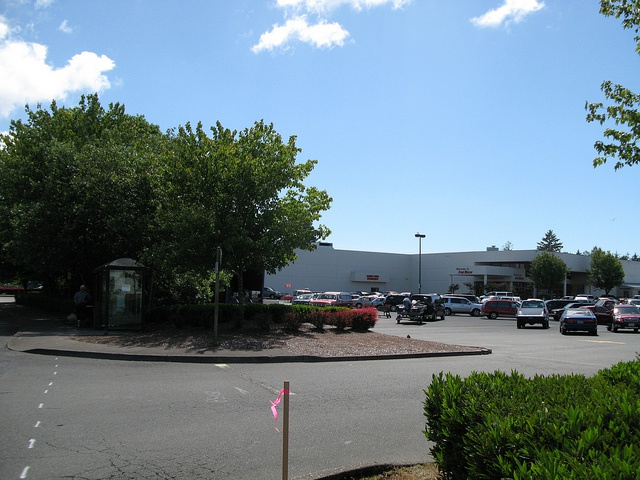Describe the objects in this image and their specific colors. I can see truck in lightblue, black, gray, and darkgray tones, car in lightblue, black, darkgray, and gray tones, car in lightblue, black, gray, blue, and darkgray tones, car in lightblue, black, blue, gray, and darkblue tones, and car in lightblue, black, gray, and darkblue tones in this image. 